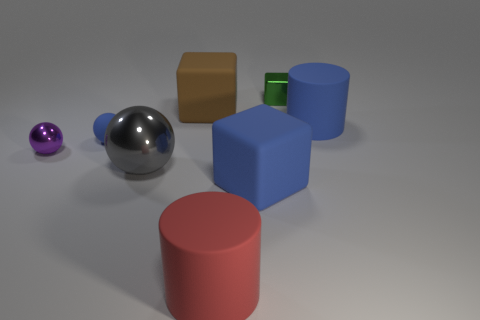How many things are big cyan matte balls or blue things that are on the right side of the large red matte cylinder?
Provide a short and direct response. 2. There is a gray object that is the same size as the red thing; what is its material?
Provide a short and direct response. Metal. There is a blue object that is behind the small purple metal ball and on the right side of the red matte object; what material is it?
Provide a succinct answer. Rubber. Are there any big blue things in front of the large rubber cylinder that is to the right of the small green metallic block?
Your answer should be very brief. Yes. There is a shiny object that is both on the right side of the blue rubber ball and behind the large gray sphere; what size is it?
Offer a very short reply. Small. What number of blue things are either cylinders or matte blocks?
Your answer should be very brief. 2. What shape is the green metal thing that is the same size as the purple object?
Provide a short and direct response. Cube. How many other things are the same color as the tiny matte sphere?
Keep it short and to the point. 2. There is a rubber block on the left side of the cylinder that is in front of the small metallic sphere; what is its size?
Give a very brief answer. Large. Does the cylinder behind the purple thing have the same material as the tiny blue object?
Provide a succinct answer. Yes. 